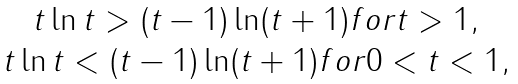<formula> <loc_0><loc_0><loc_500><loc_500>\begin{array} { c } t \ln t > ( t - 1 ) \ln ( t + 1 ) f o r t > 1 , \\ t \ln t < ( t - 1 ) \ln ( t + 1 ) f o r 0 < t < 1 , \end{array}</formula> 